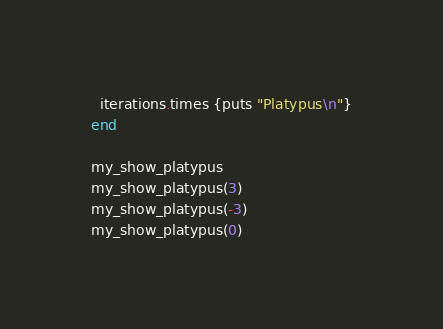Convert code to text. <code><loc_0><loc_0><loc_500><loc_500><_Ruby_>  iterations.times {puts "Platypus\n"}
end

my_show_platypus
my_show_platypus(3)
my_show_platypus(-3)
my_show_platypus(0)
</code> 